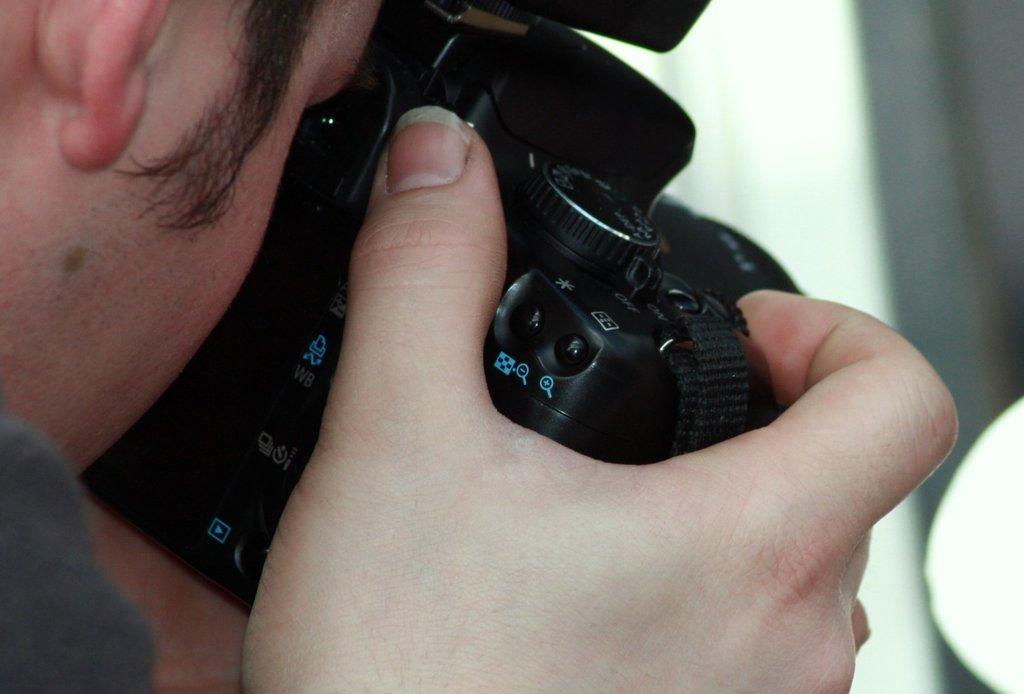What is the main subject of the image? There is a person in the image. What is the person holding in the image? The person is holding a camera. What is the color of the camera? The camera is black in color. What type of quilt is being used to cover the sky in the image? There is no quilt present in the image, nor is the sky being covered by any object. 